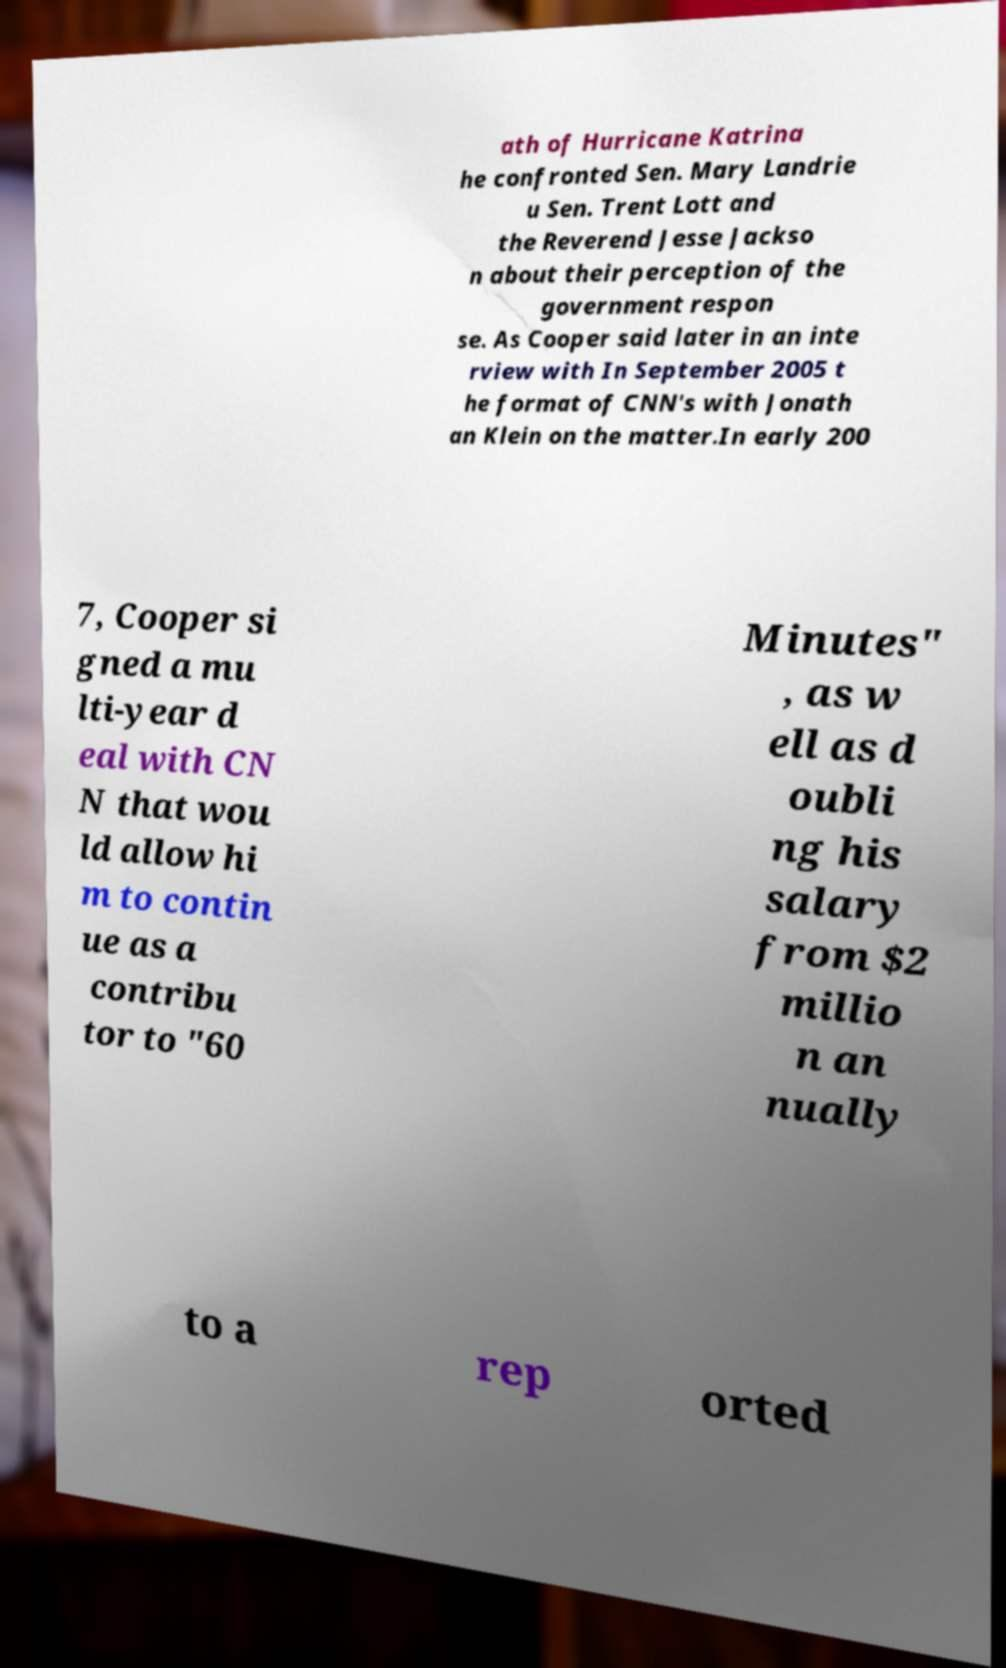Could you assist in decoding the text presented in this image and type it out clearly? ath of Hurricane Katrina he confronted Sen. Mary Landrie u Sen. Trent Lott and the Reverend Jesse Jackso n about their perception of the government respon se. As Cooper said later in an inte rview with In September 2005 t he format of CNN's with Jonath an Klein on the matter.In early 200 7, Cooper si gned a mu lti-year d eal with CN N that wou ld allow hi m to contin ue as a contribu tor to "60 Minutes" , as w ell as d oubli ng his salary from $2 millio n an nually to a rep orted 